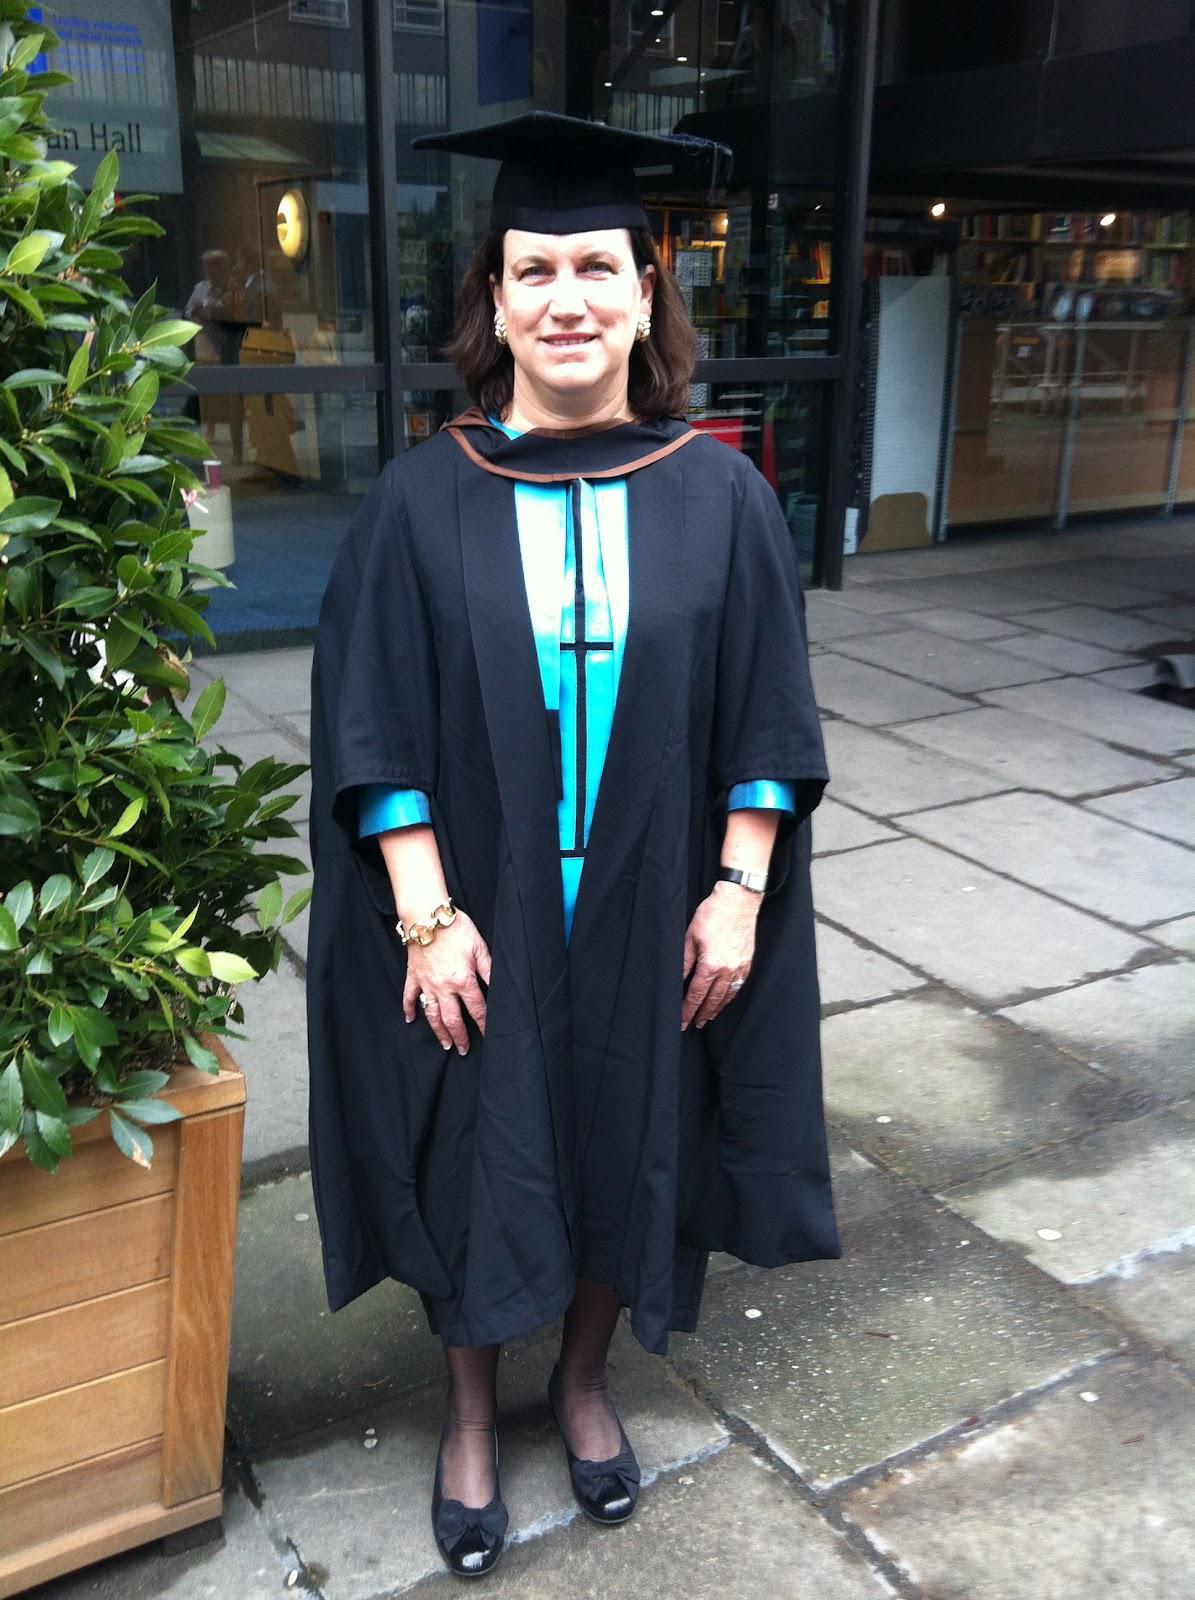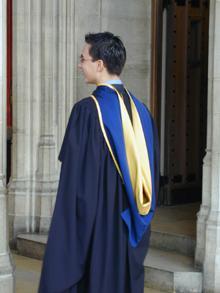The first image is the image on the left, the second image is the image on the right. For the images displayed, is the sentence "Each image shows a real person modeling graduation attire, with one image showing a front view and the other image showing a rear view." factually correct? Answer yes or no. Yes. The first image is the image on the left, the second image is the image on the right. Analyze the images presented: Is the assertion "The graduation attire in one of the images is draped over a mannequin." valid? Answer yes or no. No. 